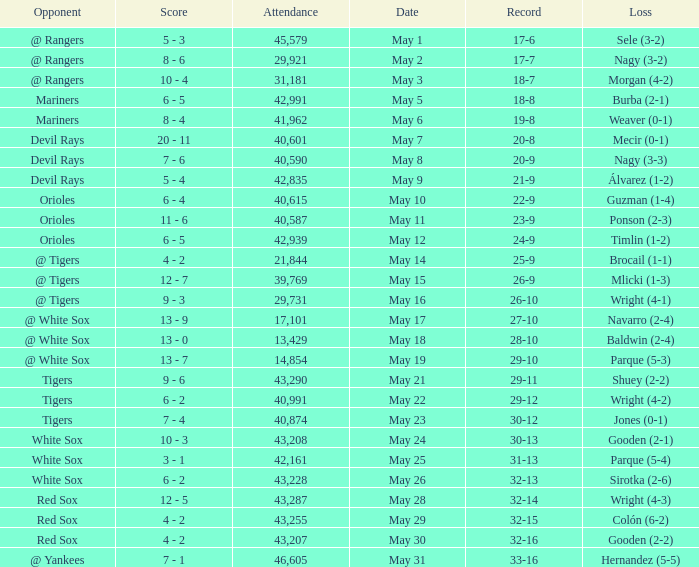What loss has 26-9 as a loss? Mlicki (1-3). 